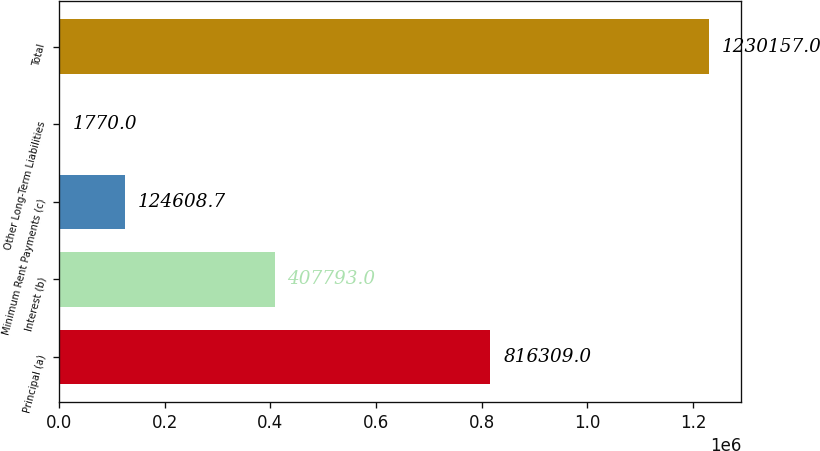Convert chart to OTSL. <chart><loc_0><loc_0><loc_500><loc_500><bar_chart><fcel>Principal (a)<fcel>Interest (b)<fcel>Minimum Rent Payments (c)<fcel>Other Long-Term Liabilities<fcel>Total<nl><fcel>816309<fcel>407793<fcel>124609<fcel>1770<fcel>1.23016e+06<nl></chart> 